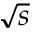Convert formula to latex. <formula><loc_0><loc_0><loc_500><loc_500>\sqrt { s }</formula> 